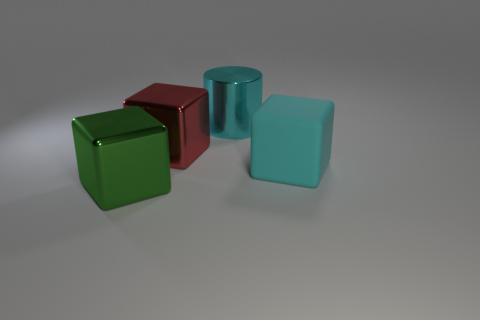Do these objects suggest a particular use or purpose? The objects seem to be simple geometric forms without any clear indication of a practical use or purpose. They may serve an educational function, demonstrating properties of color and shape, or could be part of a decorative set. 